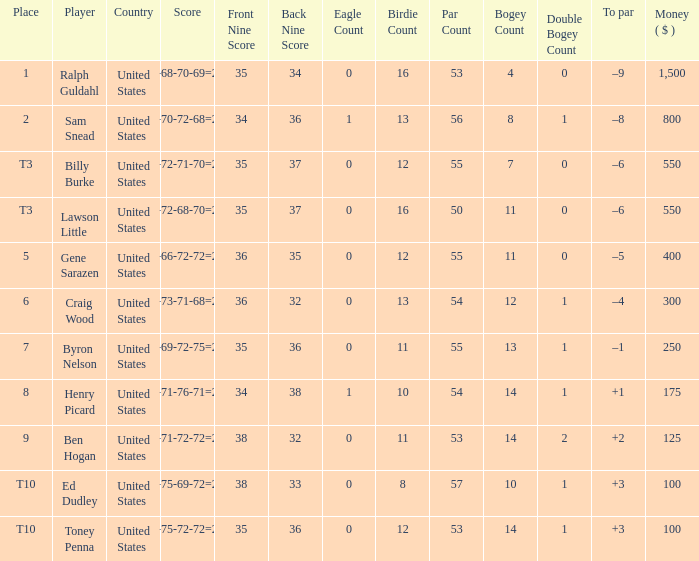Which to par has a prize less than $800? –8. 